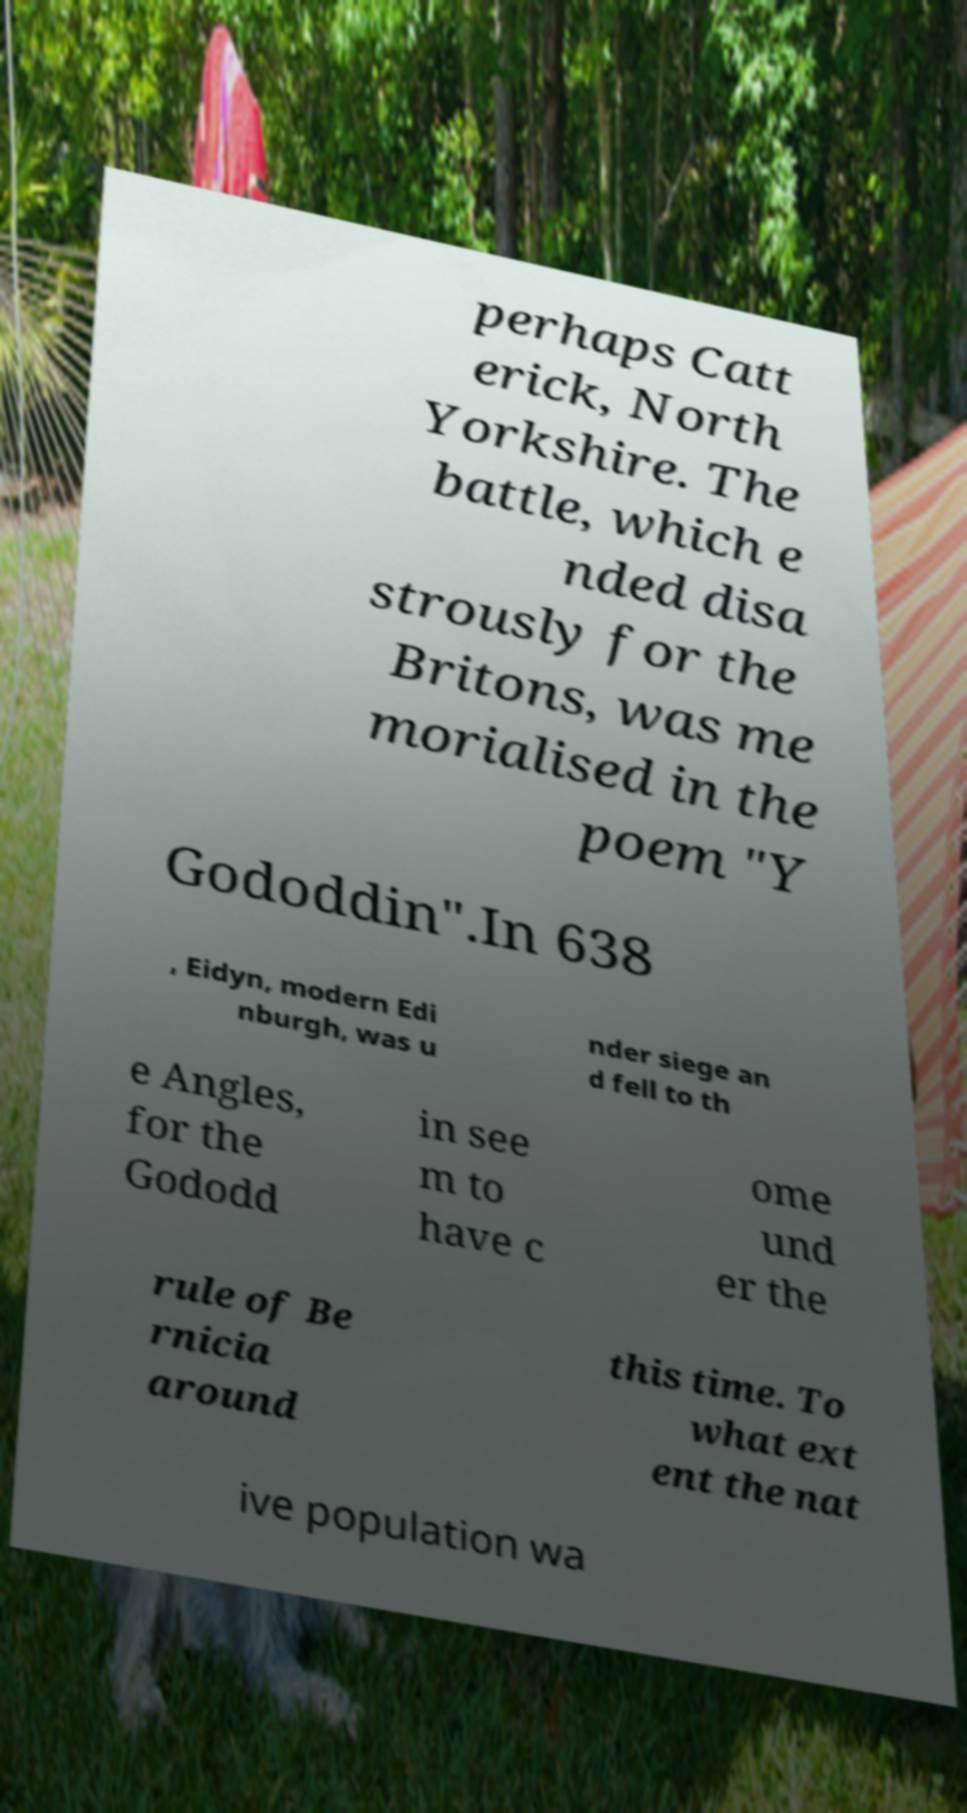I need the written content from this picture converted into text. Can you do that? perhaps Catt erick, North Yorkshire. The battle, which e nded disa strously for the Britons, was me morialised in the poem "Y Gododdin".In 638 , Eidyn, modern Edi nburgh, was u nder siege an d fell to th e Angles, for the Gododd in see m to have c ome und er the rule of Be rnicia around this time. To what ext ent the nat ive population wa 